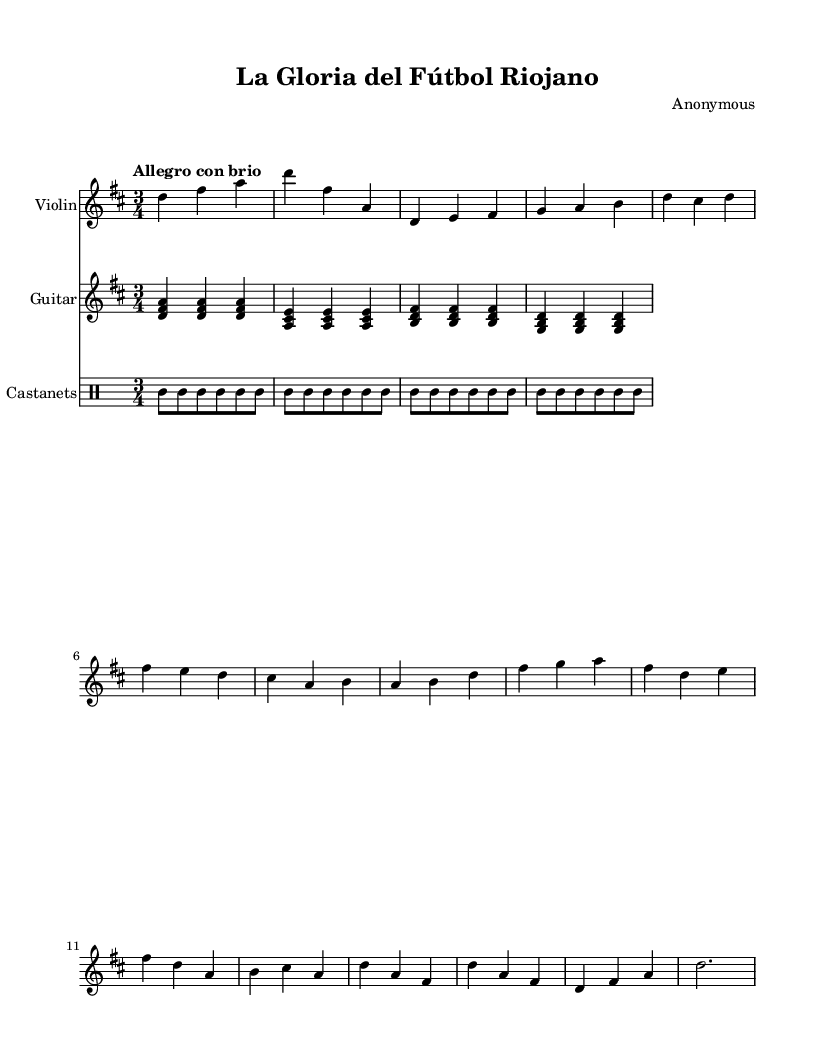What is the key signature of this music? The key signature can be identified by looking at the beginning of the staff, where there are two sharps (F# and C#). This indicates that the piece is in the key of D major.
Answer: D major What is the time signature of this music? The time signature is found after the key signature, indicated by the fraction that appears on the staff. In this case, it is 3/4, which means there are three beats in a measure, and the quarter note gets one beat.
Answer: 3/4 What is the tempo marking for this piece? The tempo marking "Allegro con brio" is written above the staff, indicating the speed of the piece. "Allegro" suggests a fast tempo, while "brio" adds an element of spiritedness to the performance.
Answer: Allegro con brio How many main themes are presented in this composition? By examining the structure laid out in the sheet music, we can observe two distinct themes: Theme A and Theme B. This is indicated clearly in the music sections.
Answer: Two What instruments are included in this score? The score contains three parts, which can be identified by their respective staff labels: Violin, Guitar, and Castanets. These instruments collectively create the composition.
Answer: Violin, Guitar, Castanets What type of rhythm do the castanets follow? The castanets in this score use a simple rhythm pattern consisting of repeating quarter notes, which serves to reinforce the rhythmic foundation of the piece. This pattern is indicated in the drummode section.
Answer: Quarter notes What is the structure of the composition as indicated in the sheet music? The sheet music layout shows an introduction followed by two themes (Theme A and Theme B), and concludes with a coda. This structured approach is typical in classical compositions.
Answer: Introduction, Theme A, Theme B, Coda 